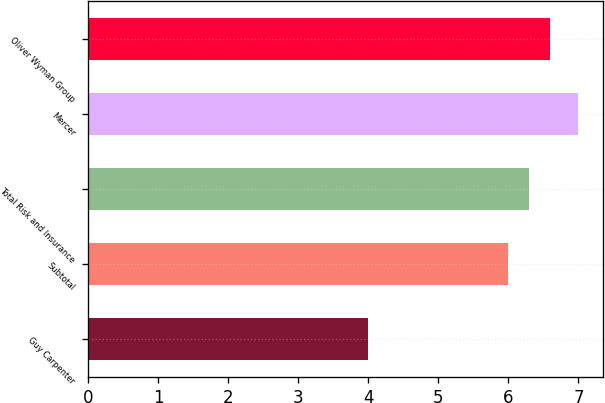<chart> <loc_0><loc_0><loc_500><loc_500><bar_chart><fcel>Guy Carpenter<fcel>Subtotal<fcel>Total Risk and Insurance<fcel>Mercer<fcel>Oliver Wyman Group<nl><fcel>4<fcel>6<fcel>6.3<fcel>7<fcel>6.6<nl></chart> 